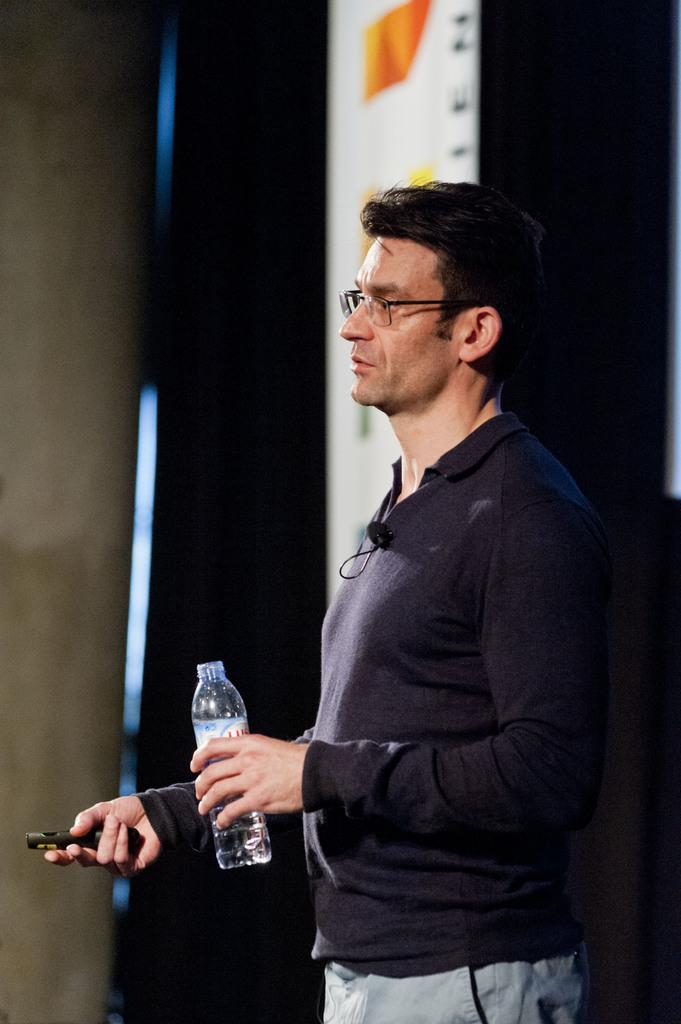What is the main subject of the image? There is a man in the image. What is the man doing in the image? The man is standing in the image. What is the man holding in the image? The man is holding a bottle and an unspecified object. What is the man wearing in the image? The man is wearing a t-shirt in the image. What can be seen in the background of the image? There is a banner in the background of the image. What type of sock is the man wearing in the image? The image does not show the man wearing any socks, so it cannot be determined from the image. 